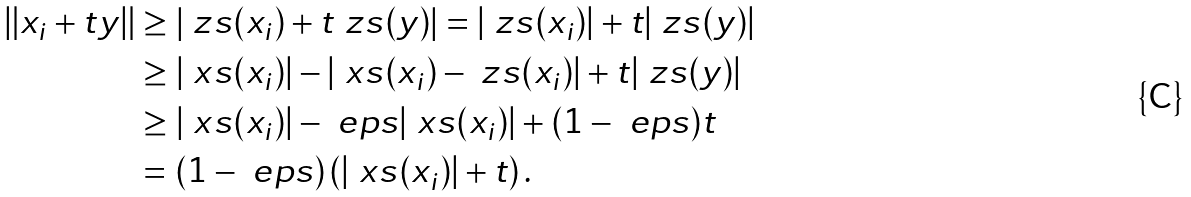Convert formula to latex. <formula><loc_0><loc_0><loc_500><loc_500>\| x _ { i } + t y \| & \geq \left | \ z s ( x _ { i } ) + t \ z s ( y ) \right | = | \ z s ( x _ { i } ) | + t | \ z s ( y ) | \\ & \geq | \ x s ( x _ { i } ) | - | \ x s ( x _ { i } ) - \ z s ( x _ { i } ) | + t | \ z s ( y ) | \\ & \geq | \ x s ( x _ { i } ) | - \ e p s | \ x s ( x _ { i } ) | + ( 1 - \ e p s ) t \\ & = ( 1 - \ e p s ) \left ( | \ x s ( x _ { i } ) | + t \right ) .</formula> 